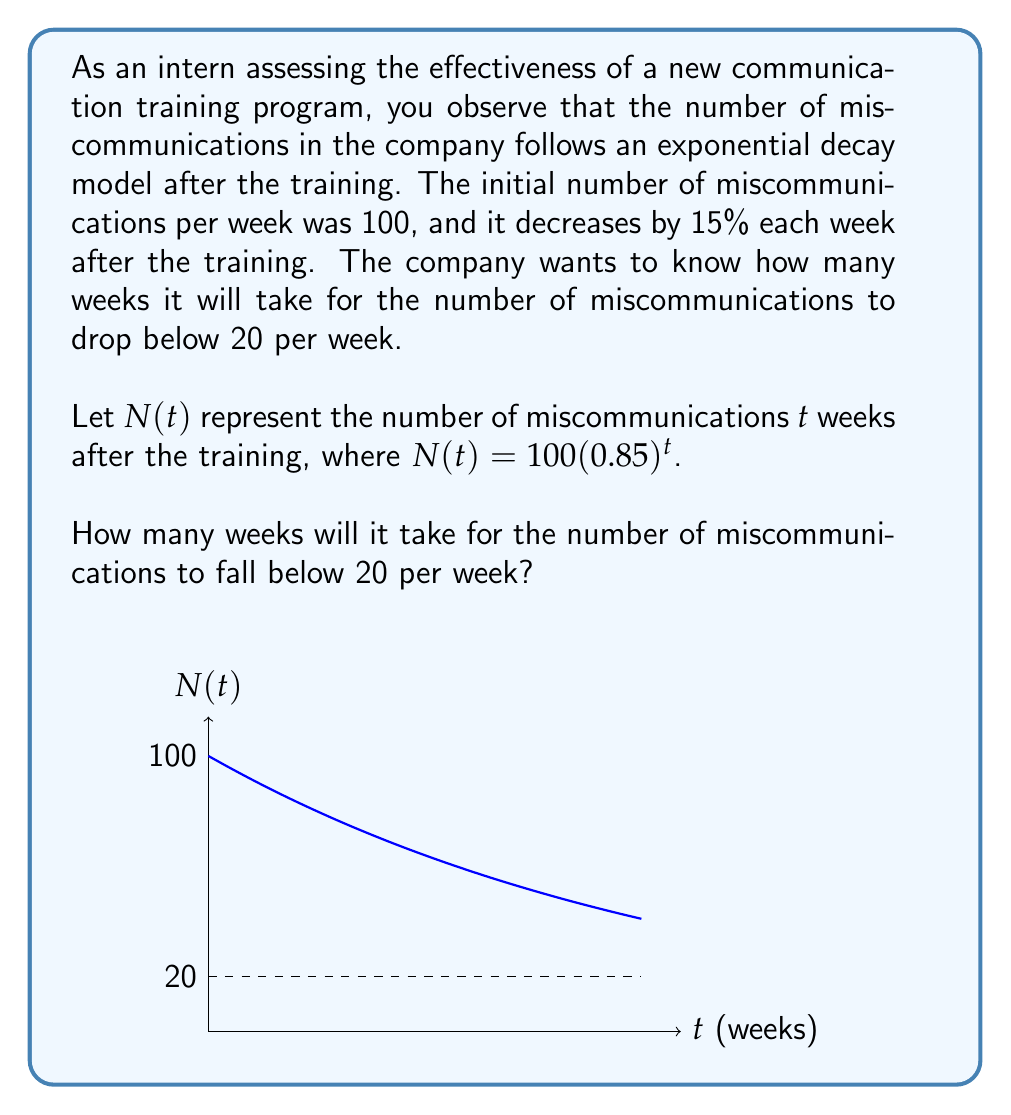Help me with this question. Let's approach this step-by-step:

1) We need to solve the inequality:
   $N(t) < 20$

2) Substituting the given function:
   $100(0.85)^t < 20$

3) Divide both sides by 100:
   $(0.85)^t < 0.2$

4) Take the natural logarithm of both sides:
   $t \ln(0.85) < \ln(0.2)$

5) Divide both sides by $\ln(0.85)$ (note that $\ln(0.85)$ is negative, so the inequality sign flips):
   $t > \frac{\ln(0.2)}{\ln(0.85)}$

6) Calculate the right-hand side:
   $t > \frac{\ln(0.2)}{\ln(0.85)} \approx 10.9752$

7) Since $t$ represents weeks and must be a whole number, we round up to the next integer:
   $t = 11$

Therefore, it will take 11 weeks for the number of miscommunications to fall below 20 per week.
Answer: 11 weeks 